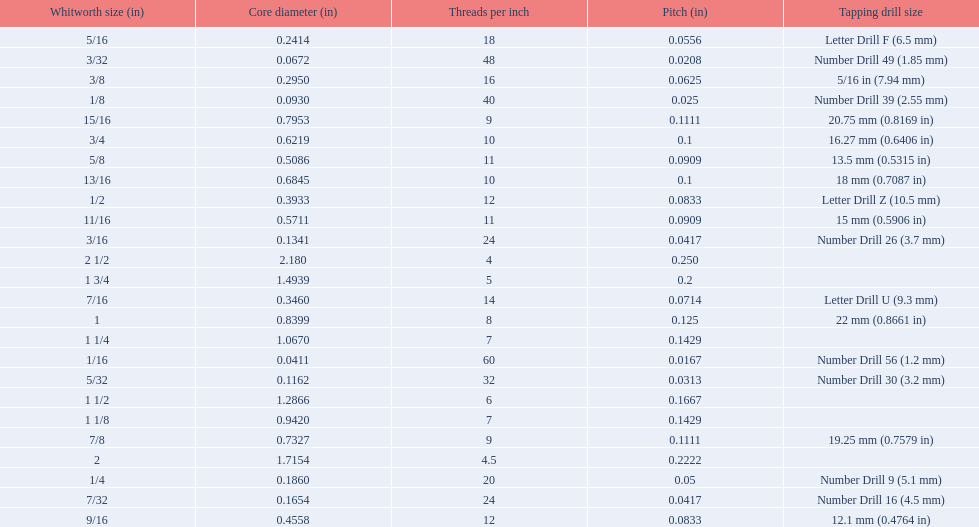What are all of the whitworth sizes in the british standard whitworth? 1/16, 3/32, 1/8, 5/32, 3/16, 7/32, 1/4, 5/16, 3/8, 7/16, 1/2, 9/16, 5/8, 11/16, 3/4, 13/16, 7/8, 15/16, 1, 1 1/8, 1 1/4, 1 1/2, 1 3/4, 2, 2 1/2. Which of these sizes uses a tapping drill size of 26? 3/16. 